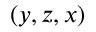Convert formula to latex. <formula><loc_0><loc_0><loc_500><loc_500>( y , z , x )</formula> 